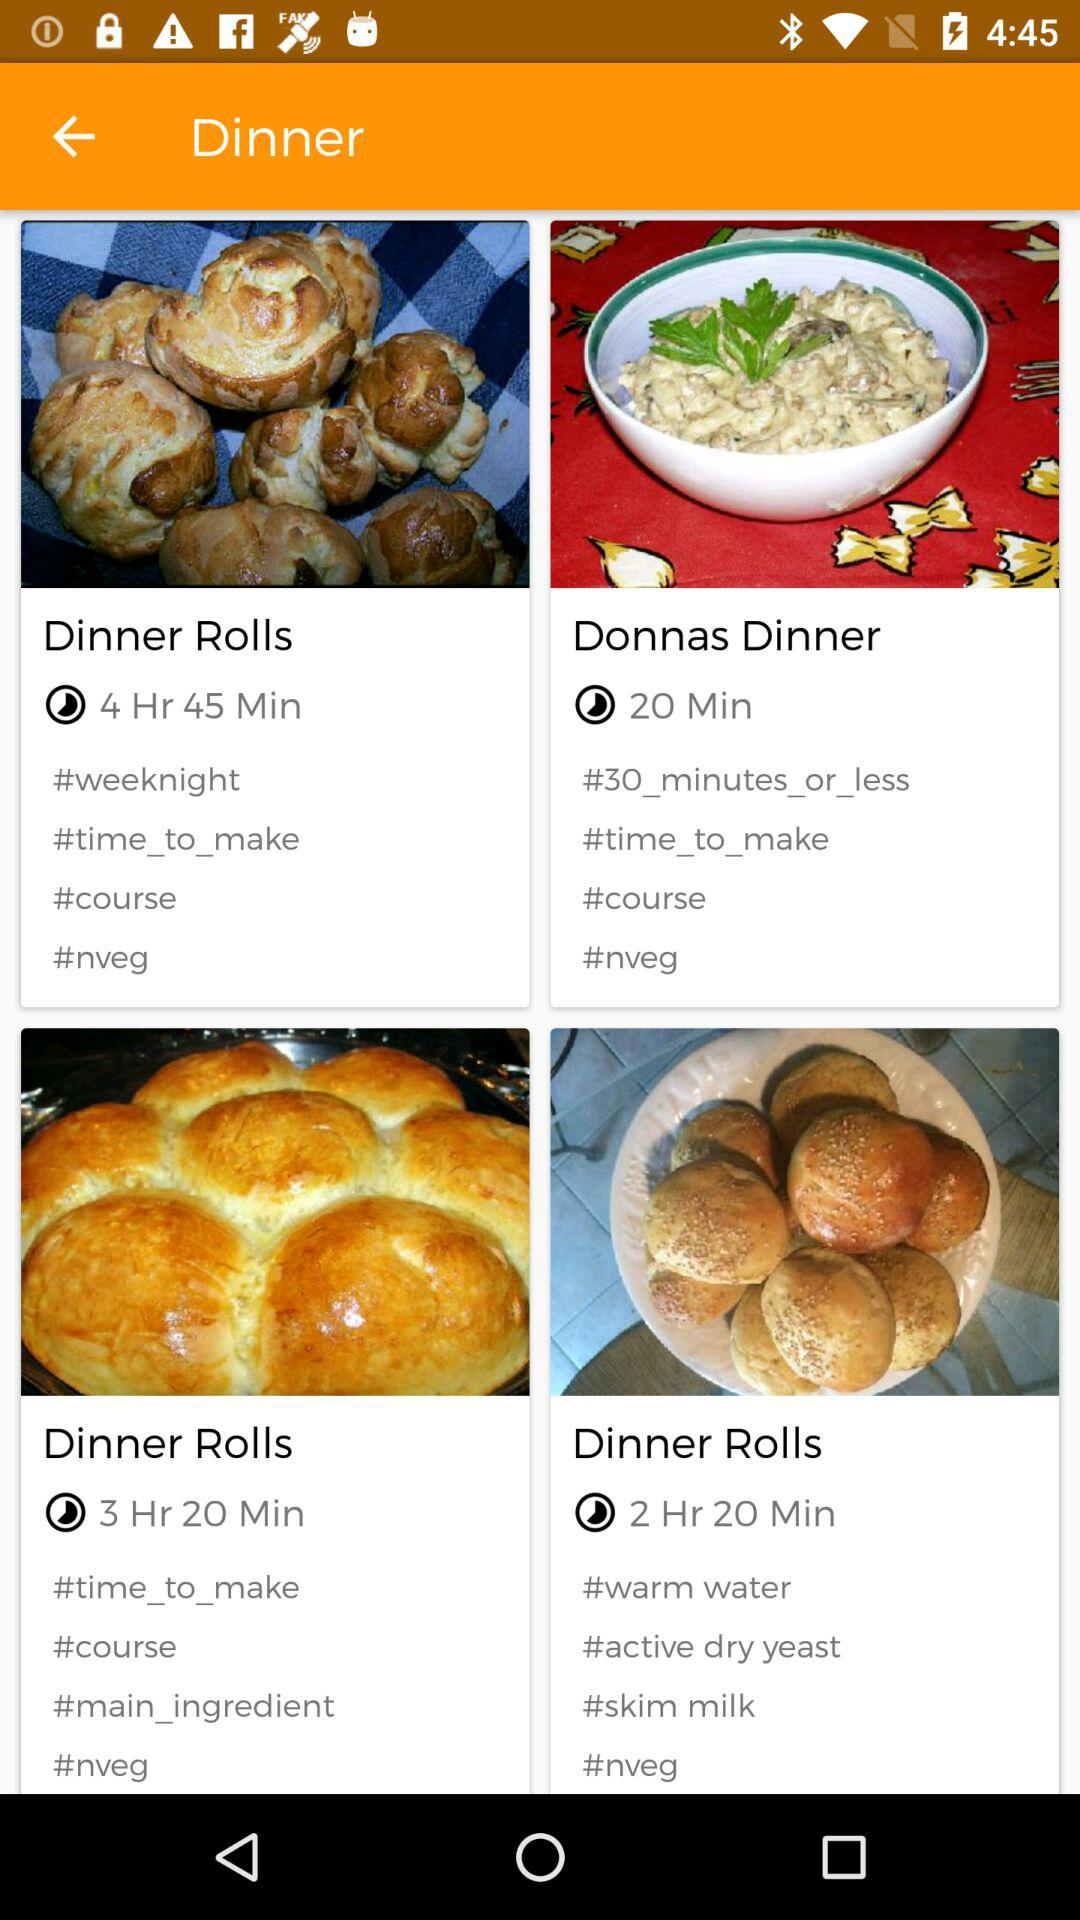What are the ingredients needed for a dinner roll that is made in 2 hours and 20 minutes? The ingredients are warm water, active dry yeast and skim milk. 